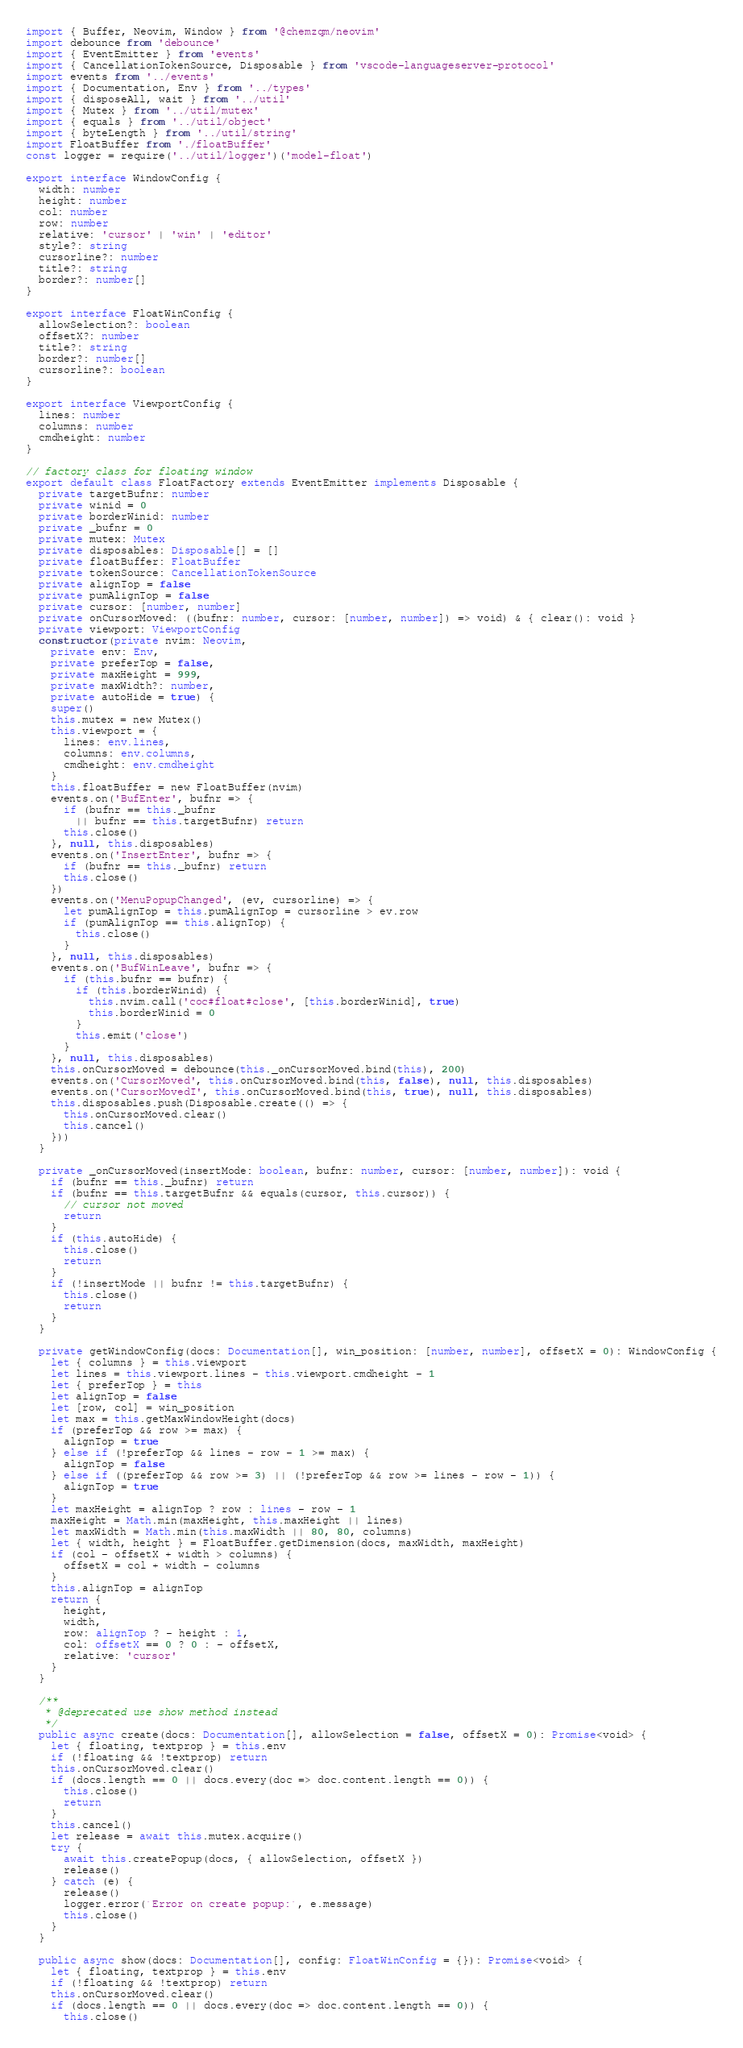Convert code to text. <code><loc_0><loc_0><loc_500><loc_500><_TypeScript_>import { Buffer, Neovim, Window } from '@chemzqm/neovim'
import debounce from 'debounce'
import { EventEmitter } from 'events'
import { CancellationTokenSource, Disposable } from 'vscode-languageserver-protocol'
import events from '../events'
import { Documentation, Env } from '../types'
import { disposeAll, wait } from '../util'
import { Mutex } from '../util/mutex'
import { equals } from '../util/object'
import { byteLength } from '../util/string'
import FloatBuffer from './floatBuffer'
const logger = require('../util/logger')('model-float')

export interface WindowConfig {
  width: number
  height: number
  col: number
  row: number
  relative: 'cursor' | 'win' | 'editor'
  style?: string
  cursorline?: number
  title?: string
  border?: number[]
}

export interface FloatWinConfig {
  allowSelection?: boolean
  offsetX?: number
  title?: string
  border?: number[]
  cursorline?: boolean
}

export interface ViewportConfig {
  lines: number
  columns: number
  cmdheight: number
}

// factory class for floating window
export default class FloatFactory extends EventEmitter implements Disposable {
  private targetBufnr: number
  private winid = 0
  private borderWinid: number
  private _bufnr = 0
  private mutex: Mutex
  private disposables: Disposable[] = []
  private floatBuffer: FloatBuffer
  private tokenSource: CancellationTokenSource
  private alignTop = false
  private pumAlignTop = false
  private cursor: [number, number]
  private onCursorMoved: ((bufnr: number, cursor: [number, number]) => void) & { clear(): void }
  private viewport: ViewportConfig
  constructor(private nvim: Neovim,
    private env: Env,
    private preferTop = false,
    private maxHeight = 999,
    private maxWidth?: number,
    private autoHide = true) {
    super()
    this.mutex = new Mutex()
    this.viewport = {
      lines: env.lines,
      columns: env.columns,
      cmdheight: env.cmdheight
    }
    this.floatBuffer = new FloatBuffer(nvim)
    events.on('BufEnter', bufnr => {
      if (bufnr == this._bufnr
        || bufnr == this.targetBufnr) return
      this.close()
    }, null, this.disposables)
    events.on('InsertEnter', bufnr => {
      if (bufnr == this._bufnr) return
      this.close()
    })
    events.on('MenuPopupChanged', (ev, cursorline) => {
      let pumAlignTop = this.pumAlignTop = cursorline > ev.row
      if (pumAlignTop == this.alignTop) {
        this.close()
      }
    }, null, this.disposables)
    events.on('BufWinLeave', bufnr => {
      if (this.bufnr == bufnr) {
        if (this.borderWinid) {
          this.nvim.call('coc#float#close', [this.borderWinid], true)
          this.borderWinid = 0
        }
        this.emit('close')
      }
    }, null, this.disposables)
    this.onCursorMoved = debounce(this._onCursorMoved.bind(this), 200)
    events.on('CursorMoved', this.onCursorMoved.bind(this, false), null, this.disposables)
    events.on('CursorMovedI', this.onCursorMoved.bind(this, true), null, this.disposables)
    this.disposables.push(Disposable.create(() => {
      this.onCursorMoved.clear()
      this.cancel()
    }))
  }

  private _onCursorMoved(insertMode: boolean, bufnr: number, cursor: [number, number]): void {
    if (bufnr == this._bufnr) return
    if (bufnr == this.targetBufnr && equals(cursor, this.cursor)) {
      // cursor not moved
      return
    }
    if (this.autoHide) {
      this.close()
      return
    }
    if (!insertMode || bufnr != this.targetBufnr) {
      this.close()
      return
    }
  }

  private getWindowConfig(docs: Documentation[], win_position: [number, number], offsetX = 0): WindowConfig {
    let { columns } = this.viewport
    let lines = this.viewport.lines - this.viewport.cmdheight - 1
    let { preferTop } = this
    let alignTop = false
    let [row, col] = win_position
    let max = this.getMaxWindowHeight(docs)
    if (preferTop && row >= max) {
      alignTop = true
    } else if (!preferTop && lines - row - 1 >= max) {
      alignTop = false
    } else if ((preferTop && row >= 3) || (!preferTop && row >= lines - row - 1)) {
      alignTop = true
    }
    let maxHeight = alignTop ? row : lines - row - 1
    maxHeight = Math.min(maxHeight, this.maxHeight || lines)
    let maxWidth = Math.min(this.maxWidth || 80, 80, columns)
    let { width, height } = FloatBuffer.getDimension(docs, maxWidth, maxHeight)
    if (col - offsetX + width > columns) {
      offsetX = col + width - columns
    }
    this.alignTop = alignTop
    return {
      height,
      width,
      row: alignTop ? - height : 1,
      col: offsetX == 0 ? 0 : - offsetX,
      relative: 'cursor'
    }
  }

  /**
   * @deprecated use show method instead
   */
  public async create(docs: Documentation[], allowSelection = false, offsetX = 0): Promise<void> {
    let { floating, textprop } = this.env
    if (!floating && !textprop) return
    this.onCursorMoved.clear()
    if (docs.length == 0 || docs.every(doc => doc.content.length == 0)) {
      this.close()
      return
    }
    this.cancel()
    let release = await this.mutex.acquire()
    try {
      await this.createPopup(docs, { allowSelection, offsetX })
      release()
    } catch (e) {
      release()
      logger.error(`Error on create popup:`, e.message)
      this.close()
    }
  }

  public async show(docs: Documentation[], config: FloatWinConfig = {}): Promise<void> {
    let { floating, textprop } = this.env
    if (!floating && !textprop) return
    this.onCursorMoved.clear()
    if (docs.length == 0 || docs.every(doc => doc.content.length == 0)) {
      this.close()</code> 